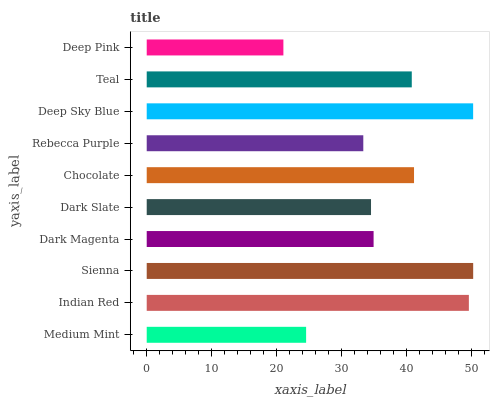Is Deep Pink the minimum?
Answer yes or no. Yes. Is Sienna the maximum?
Answer yes or no. Yes. Is Indian Red the minimum?
Answer yes or no. No. Is Indian Red the maximum?
Answer yes or no. No. Is Indian Red greater than Medium Mint?
Answer yes or no. Yes. Is Medium Mint less than Indian Red?
Answer yes or no. Yes. Is Medium Mint greater than Indian Red?
Answer yes or no. No. Is Indian Red less than Medium Mint?
Answer yes or no. No. Is Teal the high median?
Answer yes or no. Yes. Is Dark Magenta the low median?
Answer yes or no. Yes. Is Medium Mint the high median?
Answer yes or no. No. Is Medium Mint the low median?
Answer yes or no. No. 